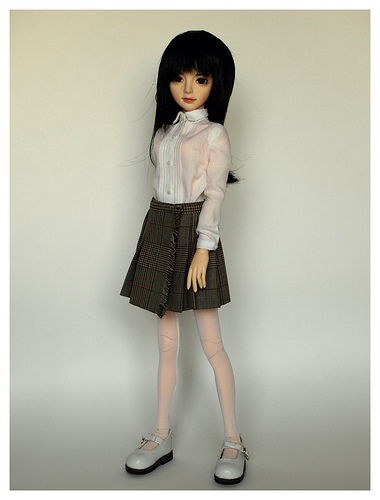<image>
Can you confirm if the skirt is on the doll? Yes. Looking at the image, I can see the skirt is positioned on top of the doll, with the doll providing support. 